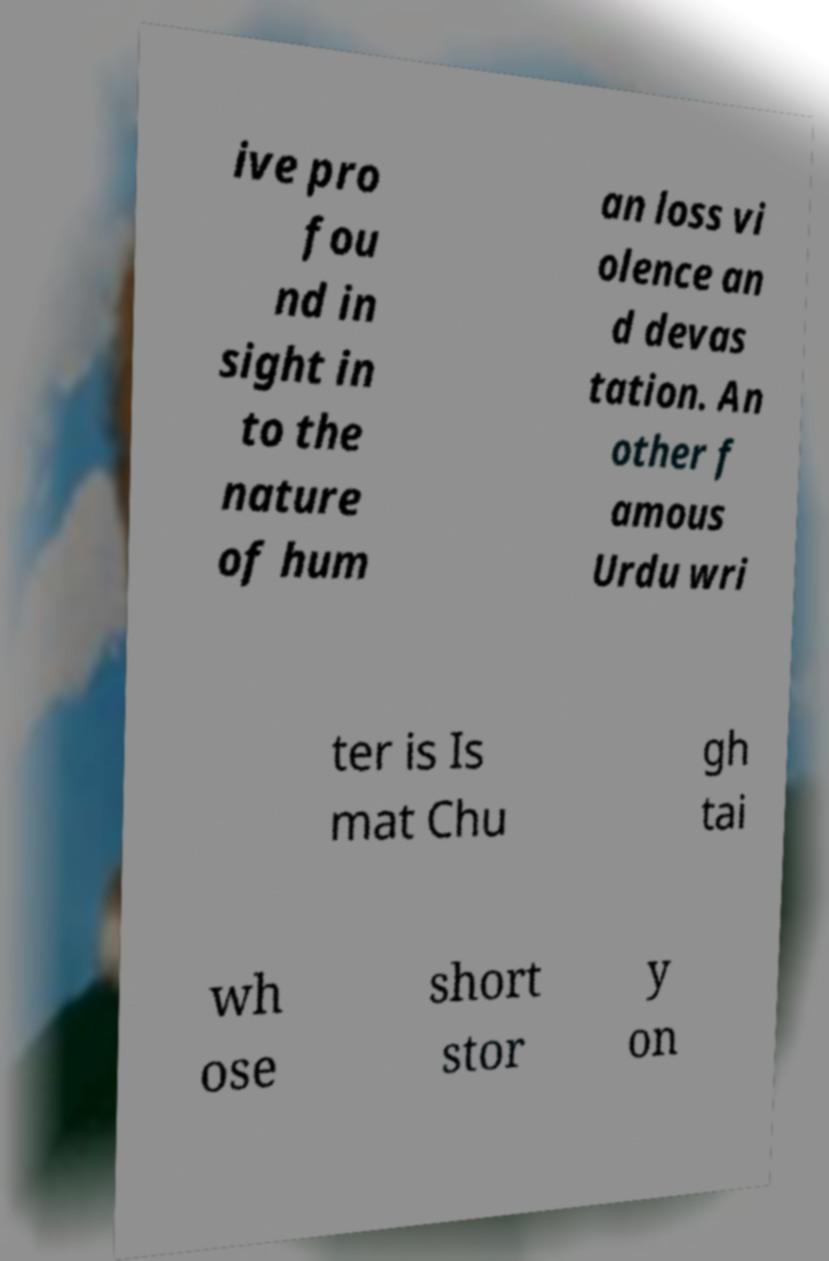Could you assist in decoding the text presented in this image and type it out clearly? ive pro fou nd in sight in to the nature of hum an loss vi olence an d devas tation. An other f amous Urdu wri ter is Is mat Chu gh tai wh ose short stor y on 